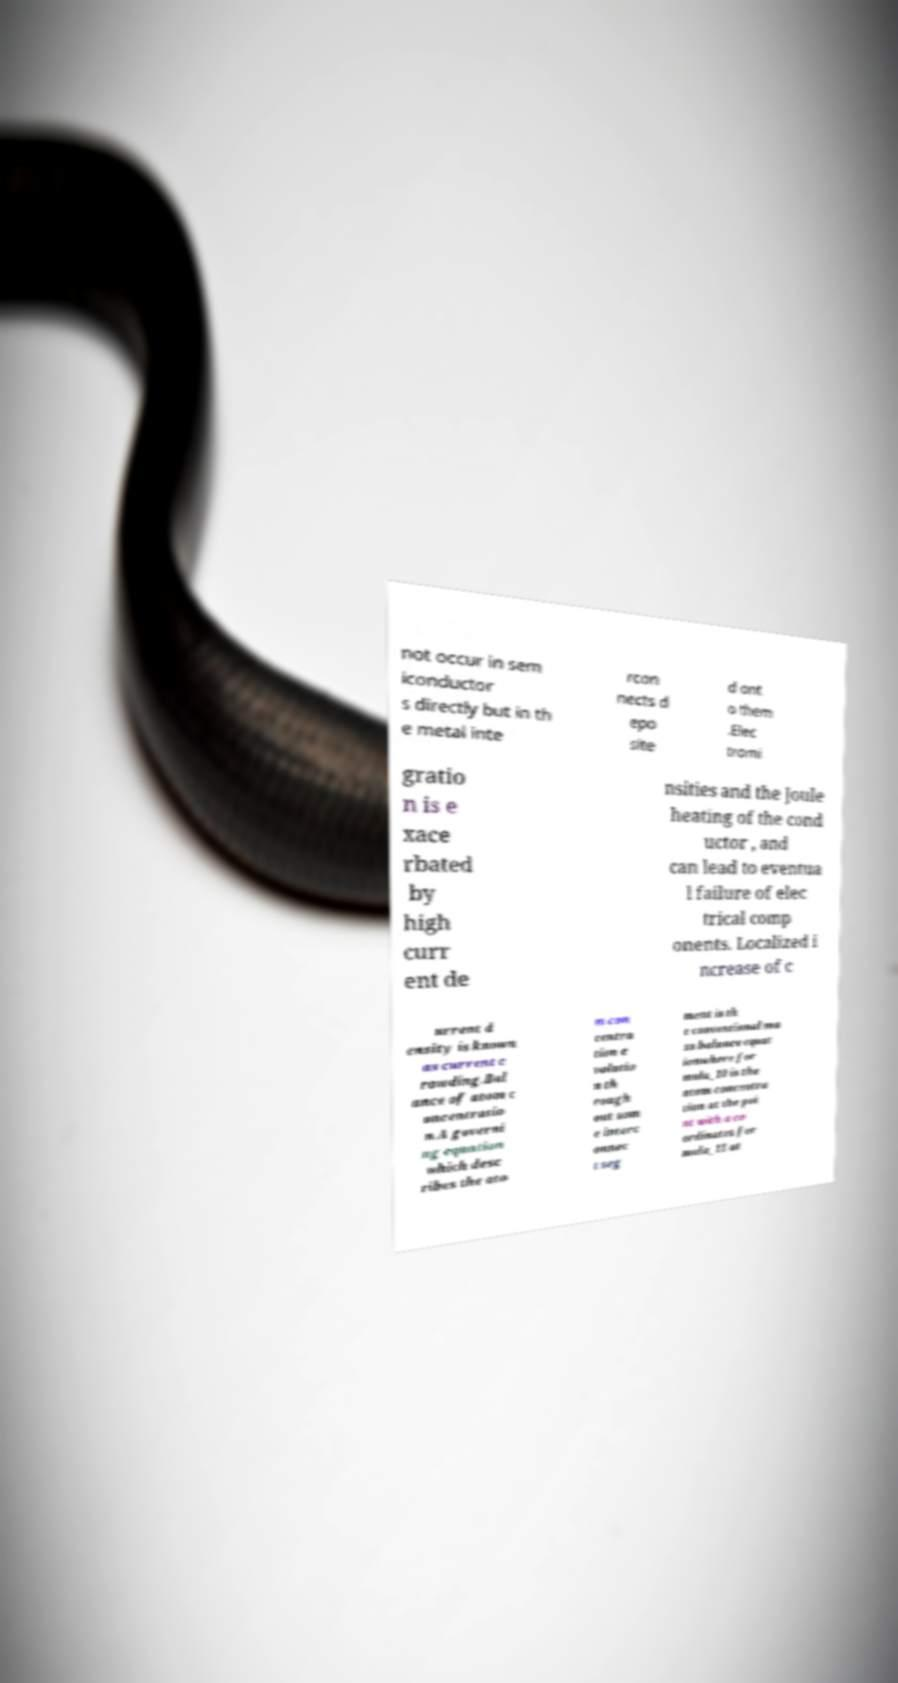Please read and relay the text visible in this image. What does it say? not occur in sem iconductor s directly but in th e metal inte rcon nects d epo site d ont o them .Elec tromi gratio n is e xace rbated by high curr ent de nsities and the Joule heating of the cond uctor , and can lead to eventua l failure of elec trical comp onents. Localized i ncrease of c urrent d ensity is known as current c rowding.Bal ance of atom c oncentratio n.A governi ng equation which desc ribes the ato m con centra tion e volutio n th rough out som e interc onnec t seg ment is th e conventional ma ss balance equat ionwhere for mula_10 is the atom concentra tion at the poi nt with a co ordinates for mula_11 at 